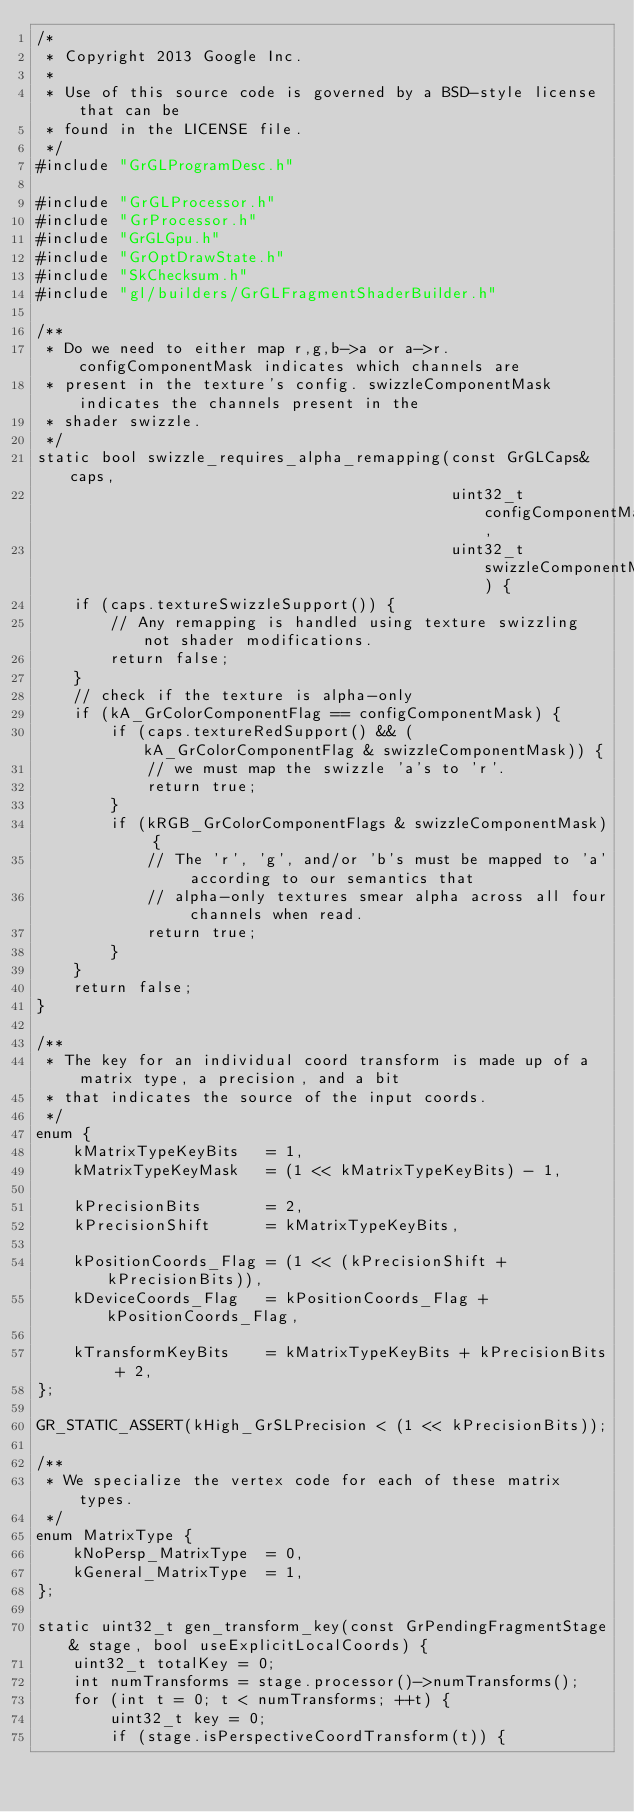<code> <loc_0><loc_0><loc_500><loc_500><_C++_>/*
 * Copyright 2013 Google Inc.
 *
 * Use of this source code is governed by a BSD-style license that can be
 * found in the LICENSE file.
 */
#include "GrGLProgramDesc.h"

#include "GrGLProcessor.h"
#include "GrProcessor.h"
#include "GrGLGpu.h"
#include "GrOptDrawState.h"
#include "SkChecksum.h"
#include "gl/builders/GrGLFragmentShaderBuilder.h"

/**
 * Do we need to either map r,g,b->a or a->r. configComponentMask indicates which channels are
 * present in the texture's config. swizzleComponentMask indicates the channels present in the
 * shader swizzle.
 */
static bool swizzle_requires_alpha_remapping(const GrGLCaps& caps,
                                             uint32_t configComponentMask,
                                             uint32_t swizzleComponentMask) {
    if (caps.textureSwizzleSupport()) {
        // Any remapping is handled using texture swizzling not shader modifications.
        return false;
    }
    // check if the texture is alpha-only
    if (kA_GrColorComponentFlag == configComponentMask) {
        if (caps.textureRedSupport() && (kA_GrColorComponentFlag & swizzleComponentMask)) {
            // we must map the swizzle 'a's to 'r'.
            return true;
        }
        if (kRGB_GrColorComponentFlags & swizzleComponentMask) {
            // The 'r', 'g', and/or 'b's must be mapped to 'a' according to our semantics that
            // alpha-only textures smear alpha across all four channels when read.
            return true;
        }
    }
    return false;
}

/**
 * The key for an individual coord transform is made up of a matrix type, a precision, and a bit
 * that indicates the source of the input coords.
 */
enum {
    kMatrixTypeKeyBits   = 1,
    kMatrixTypeKeyMask   = (1 << kMatrixTypeKeyBits) - 1,
    
    kPrecisionBits       = 2,
    kPrecisionShift      = kMatrixTypeKeyBits,

    kPositionCoords_Flag = (1 << (kPrecisionShift + kPrecisionBits)),
    kDeviceCoords_Flag   = kPositionCoords_Flag + kPositionCoords_Flag,

    kTransformKeyBits    = kMatrixTypeKeyBits + kPrecisionBits + 2,
};

GR_STATIC_ASSERT(kHigh_GrSLPrecision < (1 << kPrecisionBits));

/**
 * We specialize the vertex code for each of these matrix types.
 */
enum MatrixType {
    kNoPersp_MatrixType  = 0,
    kGeneral_MatrixType  = 1,
};

static uint32_t gen_transform_key(const GrPendingFragmentStage& stage, bool useExplicitLocalCoords) {
    uint32_t totalKey = 0;
    int numTransforms = stage.processor()->numTransforms();
    for (int t = 0; t < numTransforms; ++t) {
        uint32_t key = 0;
        if (stage.isPerspectiveCoordTransform(t)) {</code> 